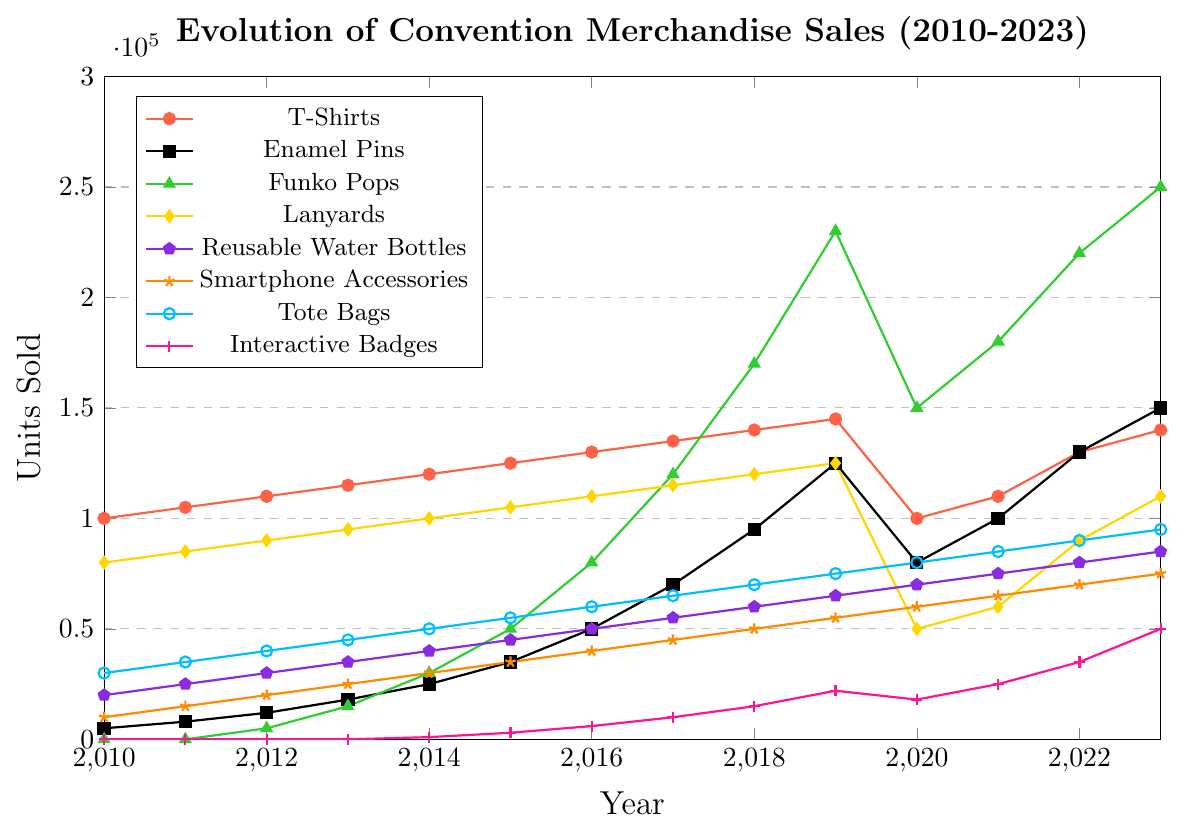How did the sales of Enamel Pins change from 2010 to 2023? Enamel Pins increased from 5,000 units sold in 2010 to 150,000 units sold in 2023.
Answer: Increased by 145,000 units Which merchandise item had the highest sales in 2023? Funko Pops had the highest sales in 2023 with 250,000 units sold.
Answer: Funko Pops Compare the sales of T-Shirts and Lanyards in 2020. Which had higher sales and by how much? In 2020, T-Shirts sold 100,000 units and Lanyards sold 50,000 units. Therefore, T-Shirts had higher sales by 50,000 units.
Answer: T-Shirts by 50,000 units What are the trends in sales for Smartphone Accessories from 2010 to 2023? Sales for Smartphone Accessories increased steadily each year from 10,000 units in 2010 to 75,000 units in 2023.
Answer: Steady increase In which year did Interactive Badges first appear in sales data, and what was their initial sales figure? Interactive Badges first appeared in the sales data in 2014 with 1,000 units sold.
Answer: 2014 with 1,000 units Between which years did Funko Pops see the largest increase in sales? The largest increase in sales for Funko Pops occurred between 2018 (170,000 units) and 2019 (230,000 units), an increase of 60,000 units.
Answer: 2018 to 2019 What was the difference in sales between Tote Bags and Reusable Water Bottles in 2023? In 2023, Tote Bags sold 95,000 units and Reusable Water Bottles sold 85,000 units, a difference of 10,000 units.
Answer: 10,000 units Calculate the average annual sales of T-Shirts from 2010 to 2023. Average annual sales = (sum of T-Shirts sales from 2010 to 2023) / number of years = (100,000 + 105,000 + 110,000 + 115,000 + 120,000 + 125,000 + 130,000 + 135,000 + 140,000 + 145,000 + 100,000 + 110,000 + 130,000 + 140,000) / 14 = 1,705,000 / 14 = 121,785.71 (rounded to 2 decimal places)
Answer: 121,785.71 units per year Which year saw the lowest sales for Lanyards, and what was the amount sold? The year 2020 saw the lowest sales for Lanyards with 50,000 units sold.
Answer: 2020 with 50,000 units Was there any item that did not show a general increase in sales from 2010 to 2023? If yes, which one and in which years did sales decrease? Lanyards showed a decrease in sales in 2020 (50,000 units), 2021 (60,000 units), and 2022 (90,000 units) compared to their respective previous years.
Answer: Lanyards in 2020, 2021, and 2022 